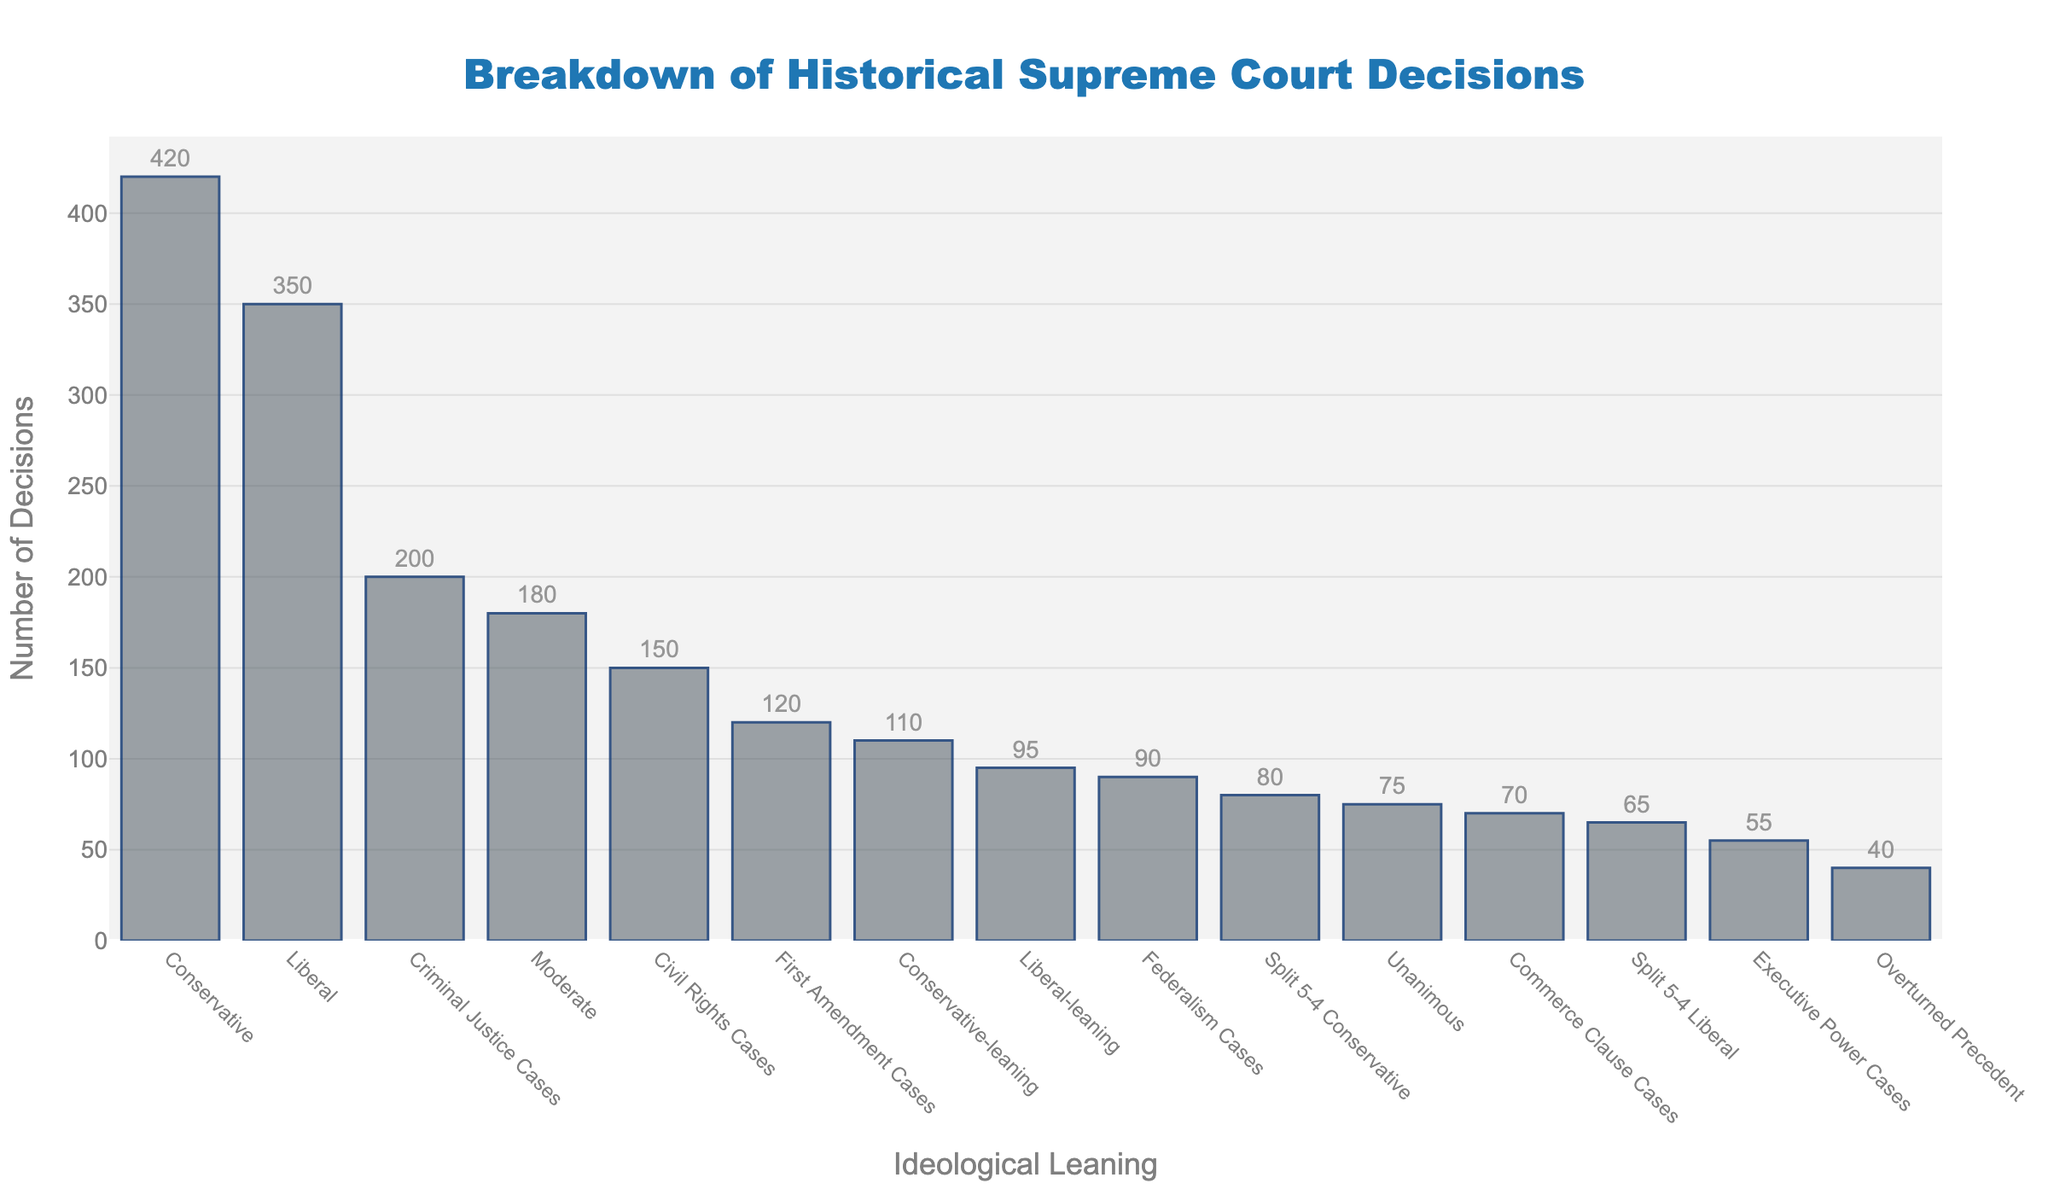What's the total number of decisions classified as Liberal and Liberal-leaning? The number of Liberal decisions is 350, and the number of Liberal-leaning decisions is 95. Adding them together gives us 350 + 95 = 445.
Answer: 445 Which category has the highest number of decisions? By observing the heights of the bars, the Conservative category has the tallest bar, representing 420 decisions.
Answer: Conservative How many more decisions were classified as Conservative than as Moderate? The number of Conservative decisions is 420, while the number of Moderate decisions is 180. Subtracting the number of Moderate decisions from Conservative decisions gives us 420 - 180 = 240.
Answer: 240 Among the categories related to Constitutional Clauses (First Amendment Cases, Civil Rights Cases, Criminal Justice Cases, Federalism Cases, Commerce Clause Cases, Executive Power Cases), which one has the fewest decisions? By comparing the heights of the bars, the Executive Power Cases category has the shortest bar, representing 55 decisions.
Answer: Executive Power Cases What is the average number of decisions across all categories? Sum the number of decisions for all categories: 350 + 420 + 180 + 95 + 110 + 75 + 65 + 80 + 40 + 120 + 150 + 200 + 90 + 70 + 55 = 2100. There are 15 categories, so divide the total by 15: 2100 / 15 = 140.
Answer: 140 Is the number of Split 5-4 Conservative decisions greater than the number of Split 5-4 Liberal decisions? The number of Split 5-4 Conservative decisions is 80, while the number of Split 5-4 Liberal decisions is 65. Since 80 is greater than 65, the answer is yes.
Answer: Yes Which category has a number of decisions closest to the median value of all categories? First, list the number of decisions in ascending order: 40, 55, 65, 70, 75, 80, 90, 95, 110, 120, 150, 180, 200, 350, 420. The median value is the middle number in this ordered list, which is the 8th value: 95. The category with decisions closest to 95 is Liberal-leaning.
Answer: Liberal-leaning How many categories have more than 100 decisions? Categories with more than 100 decisions are: Liberal (350), Conservative (420), Moderate (180), Conservative-leaning (110), First Amendment Cases (120), Civil Rights Cases (150), and Criminal Justice Cases (200). There are 7 categories in total.
Answer: 7 By how much do the decisions on Civil Rights Cases exceed those on Federalism Cases? The number of Civil Rights Cases decisions is 150, while the number of Federalism Cases decisions is 90. Subtracting the number of Federalism Cases from Civil Rights Cases gives us 150 - 90 = 60.
Answer: 60 Which bar represents unanimous decisions, and how many decisions does it account for? The bar representing unanimous decisions is labeled 'Unanimous,' and it accounts for 75 decisions.
Answer: Unanimous, 75 